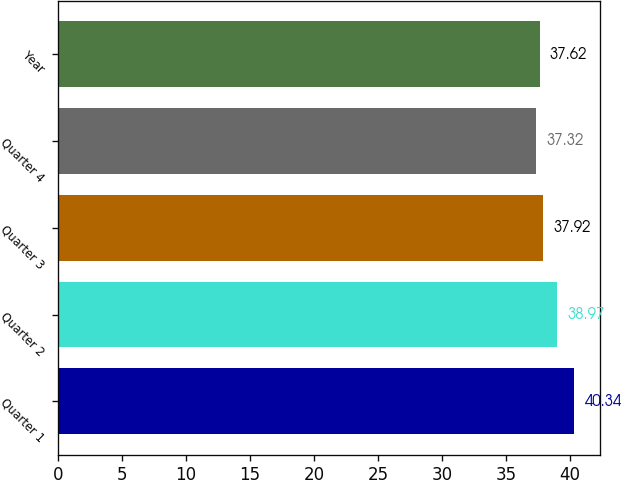Convert chart. <chart><loc_0><loc_0><loc_500><loc_500><bar_chart><fcel>Quarter 1<fcel>Quarter 2<fcel>Quarter 3<fcel>Quarter 4<fcel>Year<nl><fcel>40.34<fcel>38.97<fcel>37.92<fcel>37.32<fcel>37.62<nl></chart> 